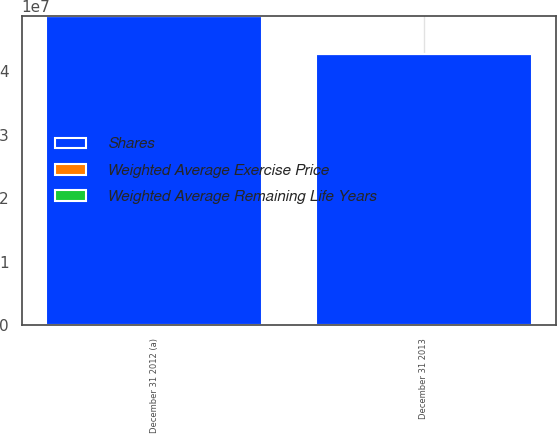Convert chart. <chart><loc_0><loc_0><loc_500><loc_500><stacked_bar_chart><ecel><fcel>December 31 2012 (a)<fcel>December 31 2013<nl><fcel>Shares<fcel>4.86853e+07<fcel>4.27573e+07<nl><fcel>Weighted Average Remaining Life Years<fcel>24.97<fcel>26.15<nl><fcel>Weighted Average Exercise Price<fcel>4<fcel>4<nl></chart> 